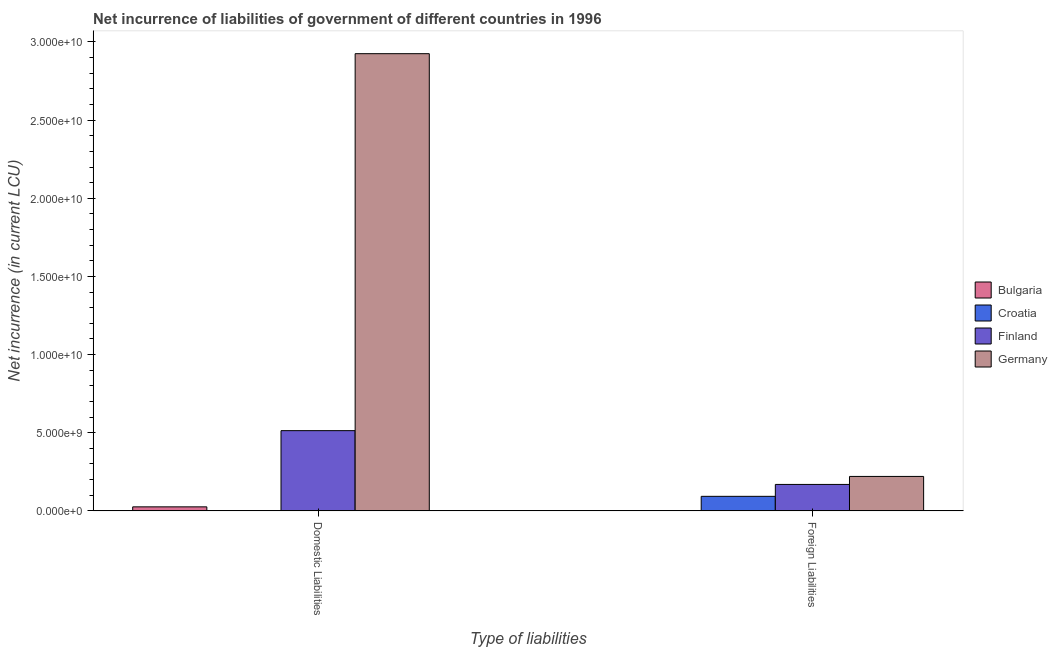How many different coloured bars are there?
Offer a terse response. 4. Are the number of bars on each tick of the X-axis equal?
Your response must be concise. Yes. What is the label of the 1st group of bars from the left?
Make the answer very short. Domestic Liabilities. What is the net incurrence of domestic liabilities in Croatia?
Ensure brevity in your answer.  0. Across all countries, what is the maximum net incurrence of domestic liabilities?
Keep it short and to the point. 2.92e+1. Across all countries, what is the minimum net incurrence of domestic liabilities?
Offer a terse response. 0. In which country was the net incurrence of foreign liabilities maximum?
Offer a very short reply. Germany. What is the total net incurrence of foreign liabilities in the graph?
Provide a succinct answer. 4.83e+09. What is the difference between the net incurrence of foreign liabilities in Finland and that in Germany?
Offer a very short reply. -5.12e+08. What is the difference between the net incurrence of domestic liabilities in Croatia and the net incurrence of foreign liabilities in Finland?
Provide a succinct answer. -1.69e+09. What is the average net incurrence of domestic liabilities per country?
Make the answer very short. 8.66e+09. What is the difference between the net incurrence of foreign liabilities and net incurrence of domestic liabilities in Finland?
Offer a very short reply. -3.44e+09. In how many countries, is the net incurrence of domestic liabilities greater than 17000000000 LCU?
Provide a short and direct response. 1. What is the ratio of the net incurrence of domestic liabilities in Bulgaria to that in Finland?
Give a very brief answer. 0.05. Is the net incurrence of foreign liabilities in Germany less than that in Finland?
Offer a very short reply. No. In how many countries, is the net incurrence of foreign liabilities greater than the average net incurrence of foreign liabilities taken over all countries?
Your answer should be very brief. 2. How many bars are there?
Provide a short and direct response. 6. What is the difference between two consecutive major ticks on the Y-axis?
Ensure brevity in your answer.  5.00e+09. Are the values on the major ticks of Y-axis written in scientific E-notation?
Provide a succinct answer. Yes. Does the graph contain any zero values?
Your answer should be compact. Yes. Does the graph contain grids?
Provide a succinct answer. No. How are the legend labels stacked?
Offer a terse response. Vertical. What is the title of the graph?
Keep it short and to the point. Net incurrence of liabilities of government of different countries in 1996. Does "India" appear as one of the legend labels in the graph?
Give a very brief answer. No. What is the label or title of the X-axis?
Your response must be concise. Type of liabilities. What is the label or title of the Y-axis?
Provide a succinct answer. Net incurrence (in current LCU). What is the Net incurrence (in current LCU) of Bulgaria in Domestic Liabilities?
Give a very brief answer. 2.58e+08. What is the Net incurrence (in current LCU) of Croatia in Domestic Liabilities?
Offer a very short reply. 0. What is the Net incurrence (in current LCU) in Finland in Domestic Liabilities?
Provide a short and direct response. 5.13e+09. What is the Net incurrence (in current LCU) of Germany in Domestic Liabilities?
Your response must be concise. 2.92e+1. What is the Net incurrence (in current LCU) of Bulgaria in Foreign Liabilities?
Your answer should be very brief. 0. What is the Net incurrence (in current LCU) in Croatia in Foreign Liabilities?
Keep it short and to the point. 9.31e+08. What is the Net incurrence (in current LCU) in Finland in Foreign Liabilities?
Offer a very short reply. 1.69e+09. What is the Net incurrence (in current LCU) of Germany in Foreign Liabilities?
Offer a very short reply. 2.20e+09. Across all Type of liabilities, what is the maximum Net incurrence (in current LCU) in Bulgaria?
Keep it short and to the point. 2.58e+08. Across all Type of liabilities, what is the maximum Net incurrence (in current LCU) of Croatia?
Provide a short and direct response. 9.31e+08. Across all Type of liabilities, what is the maximum Net incurrence (in current LCU) in Finland?
Provide a succinct answer. 5.13e+09. Across all Type of liabilities, what is the maximum Net incurrence (in current LCU) in Germany?
Give a very brief answer. 2.92e+1. Across all Type of liabilities, what is the minimum Net incurrence (in current LCU) of Bulgaria?
Ensure brevity in your answer.  0. Across all Type of liabilities, what is the minimum Net incurrence (in current LCU) of Finland?
Your response must be concise. 1.69e+09. Across all Type of liabilities, what is the minimum Net incurrence (in current LCU) of Germany?
Offer a terse response. 2.20e+09. What is the total Net incurrence (in current LCU) of Bulgaria in the graph?
Ensure brevity in your answer.  2.58e+08. What is the total Net incurrence (in current LCU) in Croatia in the graph?
Offer a very short reply. 9.31e+08. What is the total Net incurrence (in current LCU) of Finland in the graph?
Give a very brief answer. 6.83e+09. What is the total Net incurrence (in current LCU) of Germany in the graph?
Offer a terse response. 3.15e+1. What is the difference between the Net incurrence (in current LCU) of Finland in Domestic Liabilities and that in Foreign Liabilities?
Your response must be concise. 3.44e+09. What is the difference between the Net incurrence (in current LCU) in Germany in Domestic Liabilities and that in Foreign Liabilities?
Make the answer very short. 2.70e+1. What is the difference between the Net incurrence (in current LCU) in Bulgaria in Domestic Liabilities and the Net incurrence (in current LCU) in Croatia in Foreign Liabilities?
Provide a short and direct response. -6.73e+08. What is the difference between the Net incurrence (in current LCU) in Bulgaria in Domestic Liabilities and the Net incurrence (in current LCU) in Finland in Foreign Liabilities?
Provide a succinct answer. -1.44e+09. What is the difference between the Net incurrence (in current LCU) of Bulgaria in Domestic Liabilities and the Net incurrence (in current LCU) of Germany in Foreign Liabilities?
Ensure brevity in your answer.  -1.95e+09. What is the difference between the Net incurrence (in current LCU) in Finland in Domestic Liabilities and the Net incurrence (in current LCU) in Germany in Foreign Liabilities?
Provide a succinct answer. 2.93e+09. What is the average Net incurrence (in current LCU) in Bulgaria per Type of liabilities?
Give a very brief answer. 1.29e+08. What is the average Net incurrence (in current LCU) in Croatia per Type of liabilities?
Give a very brief answer. 4.66e+08. What is the average Net incurrence (in current LCU) in Finland per Type of liabilities?
Your response must be concise. 3.41e+09. What is the average Net incurrence (in current LCU) of Germany per Type of liabilities?
Your answer should be compact. 1.57e+1. What is the difference between the Net incurrence (in current LCU) of Bulgaria and Net incurrence (in current LCU) of Finland in Domestic Liabilities?
Provide a succinct answer. -4.88e+09. What is the difference between the Net incurrence (in current LCU) in Bulgaria and Net incurrence (in current LCU) in Germany in Domestic Liabilities?
Your response must be concise. -2.90e+1. What is the difference between the Net incurrence (in current LCU) in Finland and Net incurrence (in current LCU) in Germany in Domestic Liabilities?
Provide a short and direct response. -2.41e+1. What is the difference between the Net incurrence (in current LCU) of Croatia and Net incurrence (in current LCU) of Finland in Foreign Liabilities?
Offer a terse response. -7.62e+08. What is the difference between the Net incurrence (in current LCU) of Croatia and Net incurrence (in current LCU) of Germany in Foreign Liabilities?
Your answer should be compact. -1.27e+09. What is the difference between the Net incurrence (in current LCU) of Finland and Net incurrence (in current LCU) of Germany in Foreign Liabilities?
Provide a short and direct response. -5.12e+08. What is the ratio of the Net incurrence (in current LCU) in Finland in Domestic Liabilities to that in Foreign Liabilities?
Provide a short and direct response. 3.03. What is the ratio of the Net incurrence (in current LCU) in Germany in Domestic Liabilities to that in Foreign Liabilities?
Your answer should be compact. 13.27. What is the difference between the highest and the second highest Net incurrence (in current LCU) of Finland?
Offer a very short reply. 3.44e+09. What is the difference between the highest and the second highest Net incurrence (in current LCU) in Germany?
Offer a very short reply. 2.70e+1. What is the difference between the highest and the lowest Net incurrence (in current LCU) in Bulgaria?
Provide a succinct answer. 2.58e+08. What is the difference between the highest and the lowest Net incurrence (in current LCU) of Croatia?
Give a very brief answer. 9.31e+08. What is the difference between the highest and the lowest Net incurrence (in current LCU) in Finland?
Offer a very short reply. 3.44e+09. What is the difference between the highest and the lowest Net incurrence (in current LCU) in Germany?
Your response must be concise. 2.70e+1. 